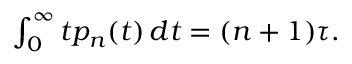Convert formula to latex. <formula><loc_0><loc_0><loc_500><loc_500>\begin{array} { r } { \int _ { 0 } ^ { \infty } t p _ { n } ( t ) \, d t = ( n + 1 ) \tau . } \end{array}</formula> 